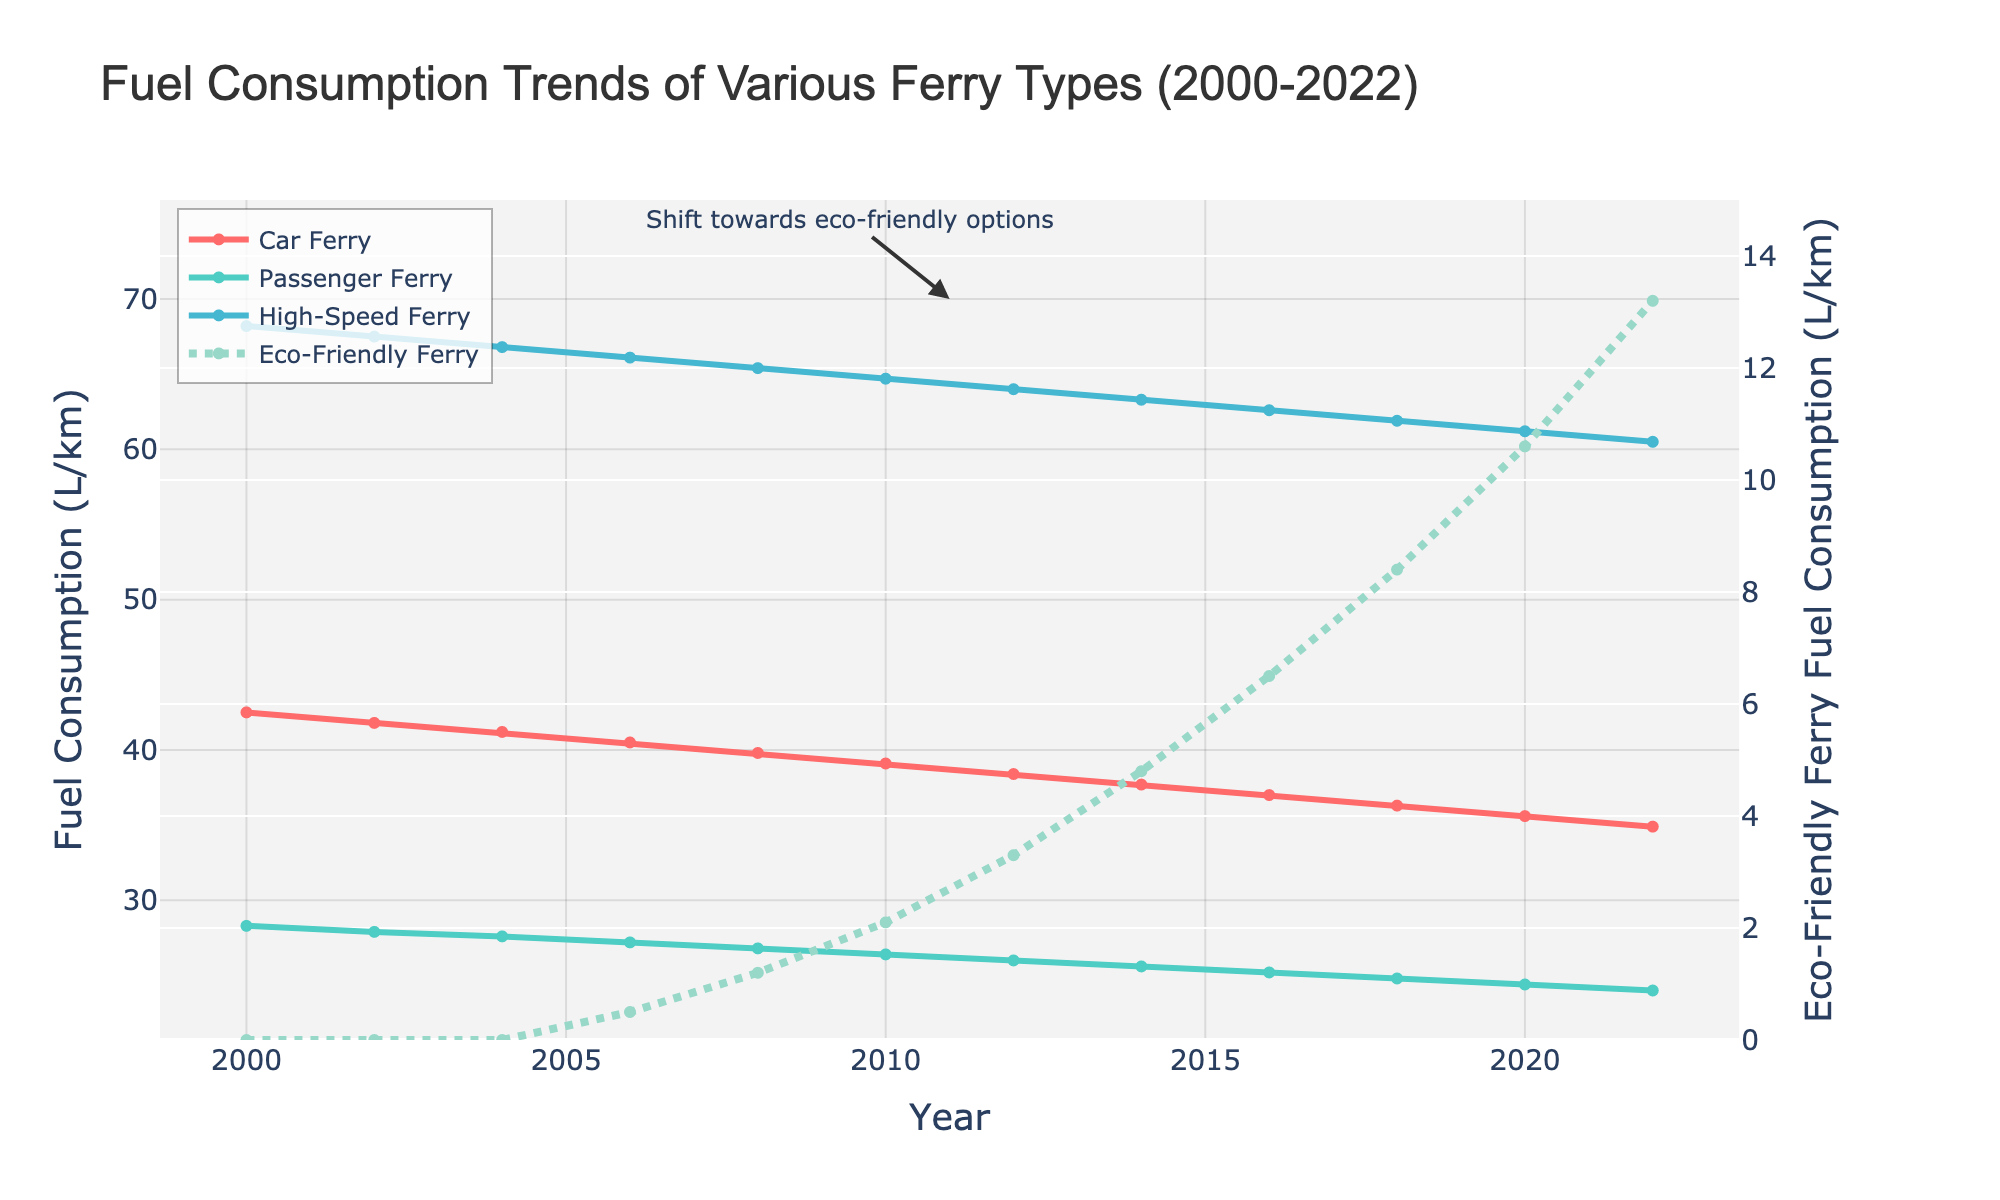What trend do you observe for the fuel consumption of passenger ferries from 2000 to 2022? The data for passenger ferries shows a consistent decrease in fuel consumption from 28.3 L/km in 2000 to 24.0 L/km in 2022. This signifies a steady improvement in fuel efficiency over the years.
Answer: Decreasing How does the fuel consumption of high-speed ferries in 2022 compare to that of car ferries in the same year? Observing the graph, high-speed ferries in 2022 have a fuel consumption of 60.5 L/km, while car ferries show 34.9 L/km. Hence, high-speed ferries consume more fuel than car ferries.
Answer: High-speed ferries consume more What was the fuel consumption difference between car ferries and eco-friendly ferries in 2010? In 2010, the fuel consumption for car ferries was 39.1 L/km, and for eco-friendly ferries, it was 2.1 L/km. The difference is 39.1 - 2.1 = 37 L/km.
Answer: 37 L/km Which year did eco-friendly ferries start appearing in the dataset, and how did their fuel consumption trend from that year onward? Eco-friendly ferries first appeared in 2006 with a consumption of 0.5 L/km. From 2006 to 2022, their consumption steadily increased to 13.2 L/km, indicating more adoption and possibly increased usage.
Answer: 2006, increasing Which ferry type showed the most significant improvement in fuel efficiency from 2000 to 2022? By examining the trends, high-speed ferries showed the greatest reduction in fuel consumption, decreasing from 68.2 L/km in 2000 to 60.5 L/km in 2022, which is a reduction of 7.7 L/km.
Answer: High-speed ferries How did fuel consumption of high-speed ferries change between 2004 and 2008? In 2004, the fuel consumption for high-speed ferries was 66.8 L/km, and it decreased to 65.4 L/km in 2008. Therefore, the change was a reduction of 66.8 - 65.4 = 1.4 L/km.
Answer: Decreased by 1.4 L/km Compare the fuel consumption of car and eco-friendly ferries in 2018. How do their values differ? In 2018, car ferries had a fuel consumption of 36.3 L/km, while eco-friendly ferries consumed 8.4 L/km. This difference is 36.3 - 8.4 = 27.9 L/km.
Answer: 27.9 L/km What can be inferred from the annotation "Shift towards eco-friendly options" on the plot? The annotation highlights a period around 2011 when there is a noticeable uptrend in the adoption and fuel consumption of eco-friendly ferries, indicating a shift towards more sustainable ferry options.
Answer: Increased eco-friendly adoption around 2011 